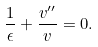<formula> <loc_0><loc_0><loc_500><loc_500>\frac { 1 } { \epsilon } + \frac { v ^ { \prime \prime } } { v } = 0 .</formula> 